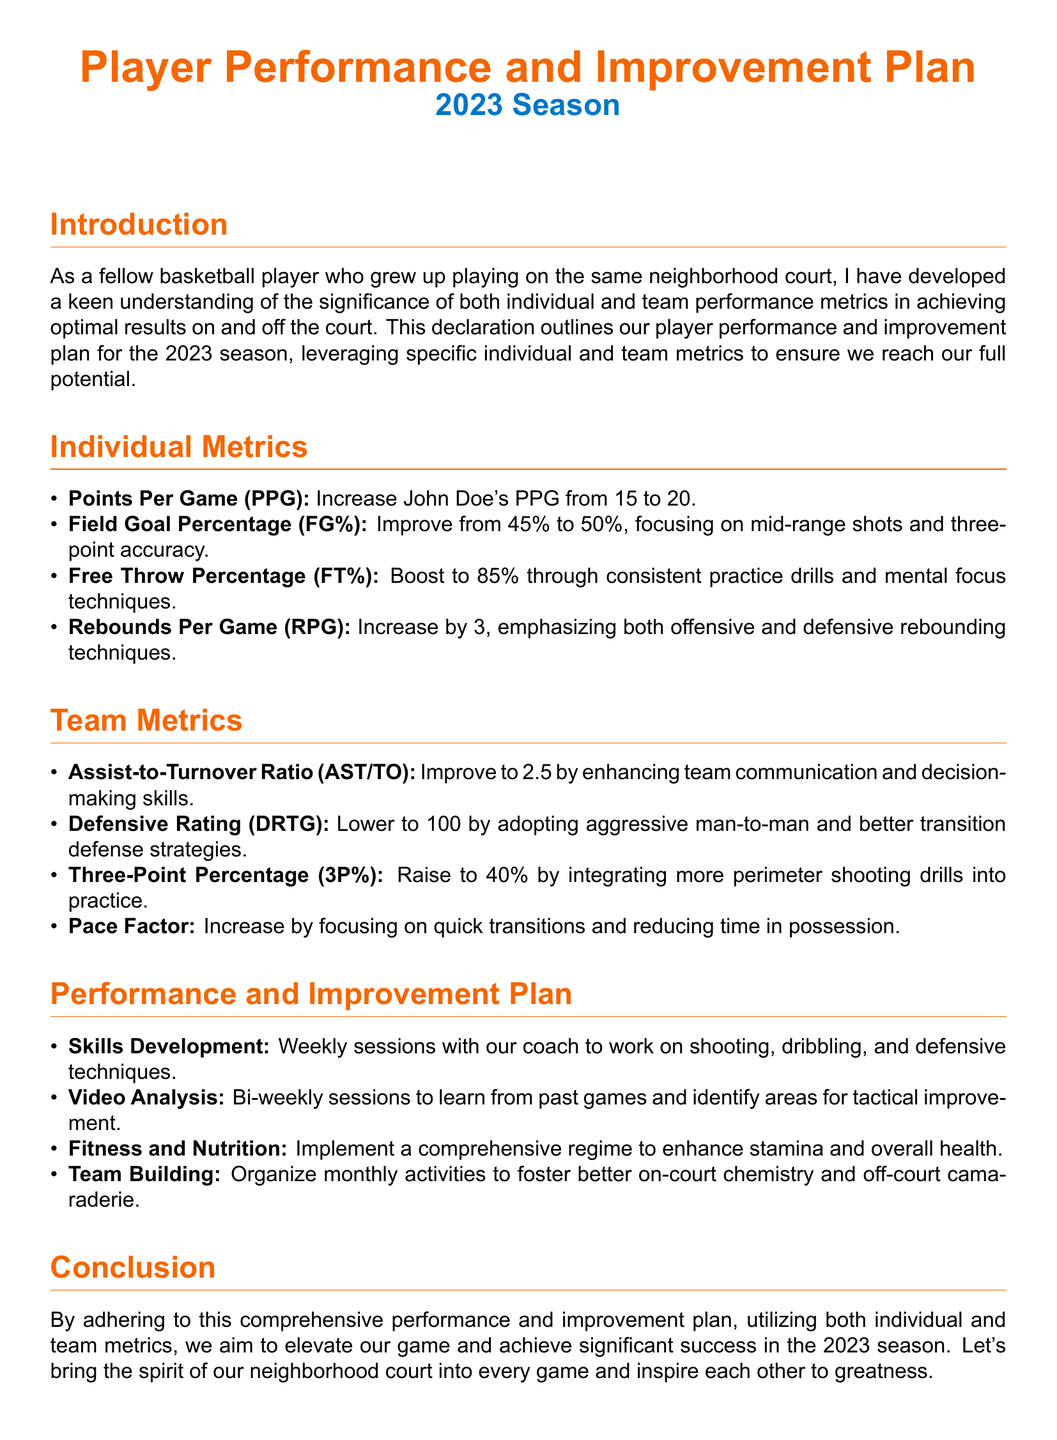What is the player’s current Points Per Game? The current Points Per Game for John Doe is 15, as stated in the individual metrics.
Answer: 15 What is the target Free Throw Percentage to be achieved? The target Free Throw Percentage to be achieved is mentioned as 85% in the individual metrics.
Answer: 85% What is the desired improvement in rebounds per game? The desired improvement in rebounds per game is an increase by 3, according to the individual metrics.
Answer: 3 What is the goal for the Assist-to-Turnover Ratio? The goal for the Assist-to-Turnover Ratio is to improve to 2.5, as outlined in the team metrics.
Answer: 2.5 What strategy is suggested to lower the Defensive Rating? The document suggests adopting aggressive man-to-man strategies to lower the Defensive Rating.
Answer: Aggressive man-to-man What is the aim for the team’s Three-Point Percentage? The aim for the team's Three-Point Percentage is to raise it to 40%, as indicated in the team metrics.
Answer: 40% What type of sessions are planned for skills development? Weekly sessions with the coach are planned for skills development, according to the performance and improvement plan.
Answer: Weekly sessions How often will video analysis sessions occur? The video analysis sessions are scheduled to occur bi-weekly, as mentioned in the performance and improvement plan.
Answer: Bi-weekly What is the focus of the fitness and nutrition regime? The focus of the fitness and nutrition regime is to enhance stamina and overall health, as stated in the performance and improvement plan.
Answer: Stamina and overall health 